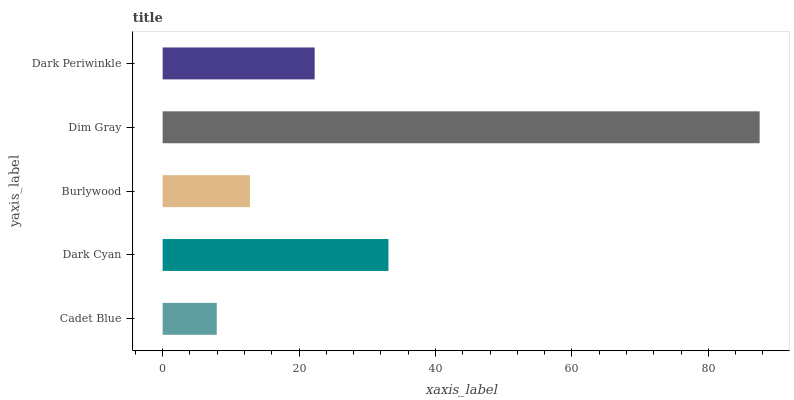Is Cadet Blue the minimum?
Answer yes or no. Yes. Is Dim Gray the maximum?
Answer yes or no. Yes. Is Dark Cyan the minimum?
Answer yes or no. No. Is Dark Cyan the maximum?
Answer yes or no. No. Is Dark Cyan greater than Cadet Blue?
Answer yes or no. Yes. Is Cadet Blue less than Dark Cyan?
Answer yes or no. Yes. Is Cadet Blue greater than Dark Cyan?
Answer yes or no. No. Is Dark Cyan less than Cadet Blue?
Answer yes or no. No. Is Dark Periwinkle the high median?
Answer yes or no. Yes. Is Dark Periwinkle the low median?
Answer yes or no. Yes. Is Dim Gray the high median?
Answer yes or no. No. Is Dark Cyan the low median?
Answer yes or no. No. 